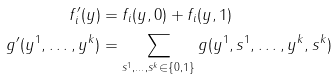<formula> <loc_0><loc_0><loc_500><loc_500>f ^ { \prime } _ { i } ( y ) & = f _ { i } ( y , 0 ) + f _ { i } ( y , 1 ) \\ g ^ { \prime } ( y ^ { 1 } , \dots , y ^ { k } ) & = \sum _ { s ^ { 1 } , \dots , s ^ { k } \in \{ 0 , 1 \} } g ( y ^ { 1 } , s ^ { 1 } , \dots , y ^ { k } , s ^ { k } )</formula> 